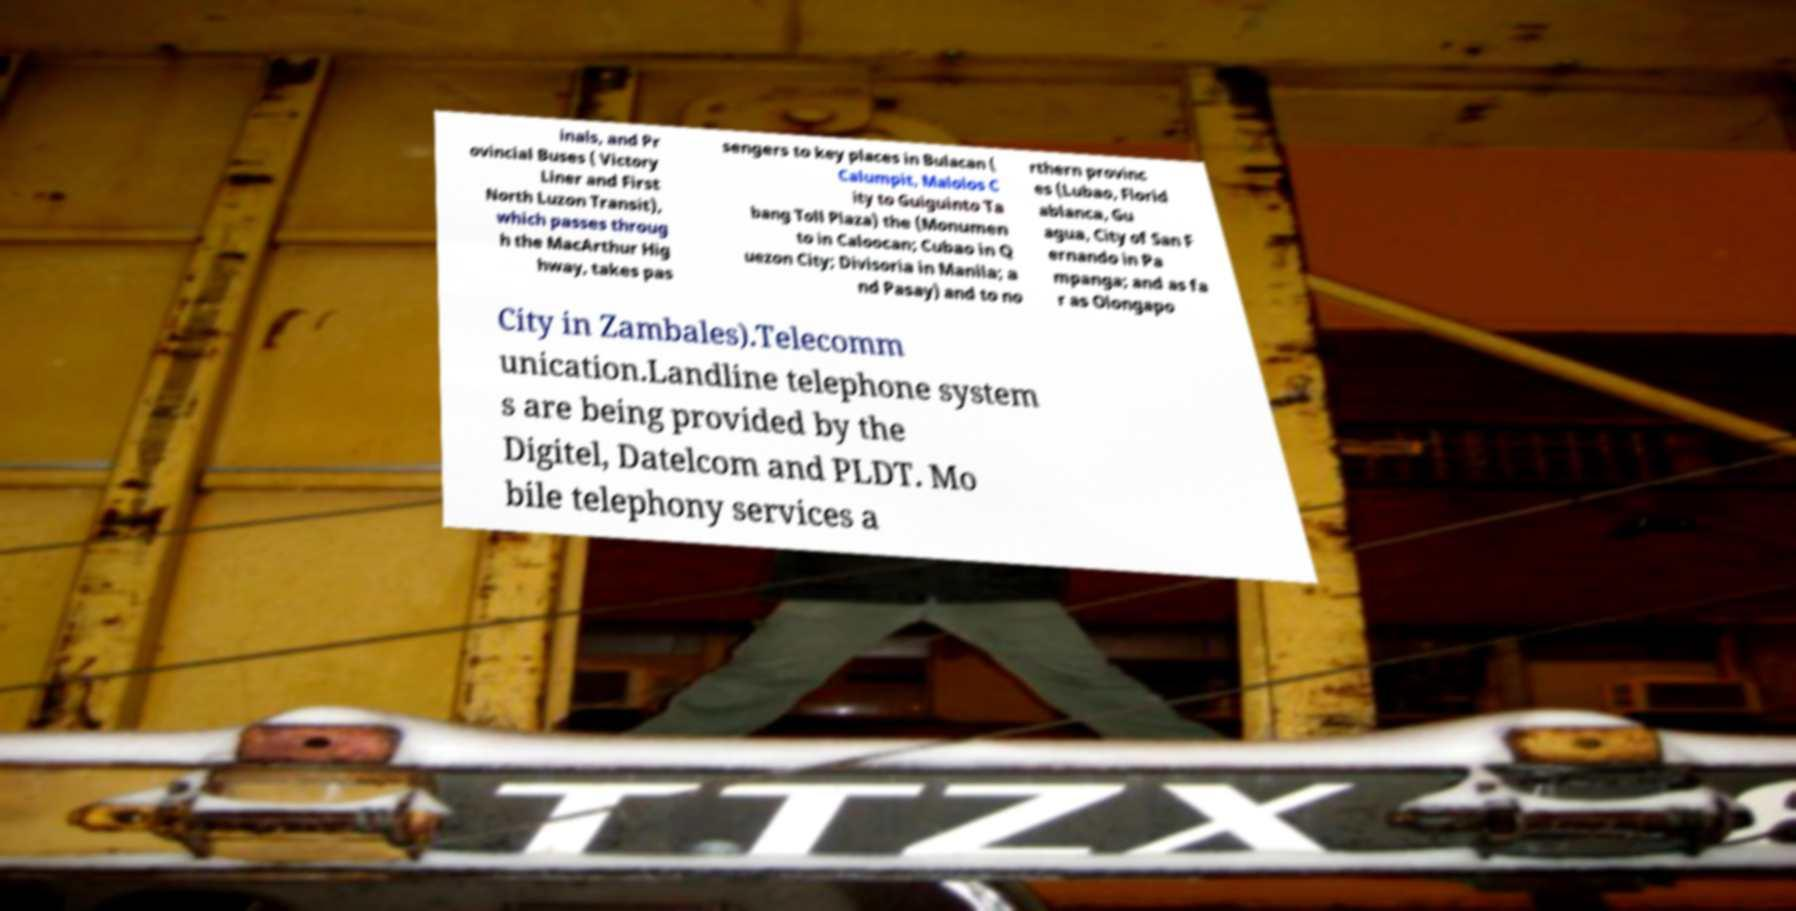What messages or text are displayed in this image? I need them in a readable, typed format. inals, and Pr ovincial Buses ( Victory Liner and First North Luzon Transit), which passes throug h the MacArthur Hig hway, takes pas sengers to key places in Bulacan ( Calumpit, Malolos C ity to Guiguinto Ta bang Toll Plaza) the (Monumen to in Caloocan; Cubao in Q uezon City; Divisoria in Manila; a nd Pasay) and to no rthern provinc es (Lubao, Florid ablanca, Gu agua, City of San F ernando in Pa mpanga; and as fa r as Olongapo City in Zambales).Telecomm unication.Landline telephone system s are being provided by the Digitel, Datelcom and PLDT. Mo bile telephony services a 